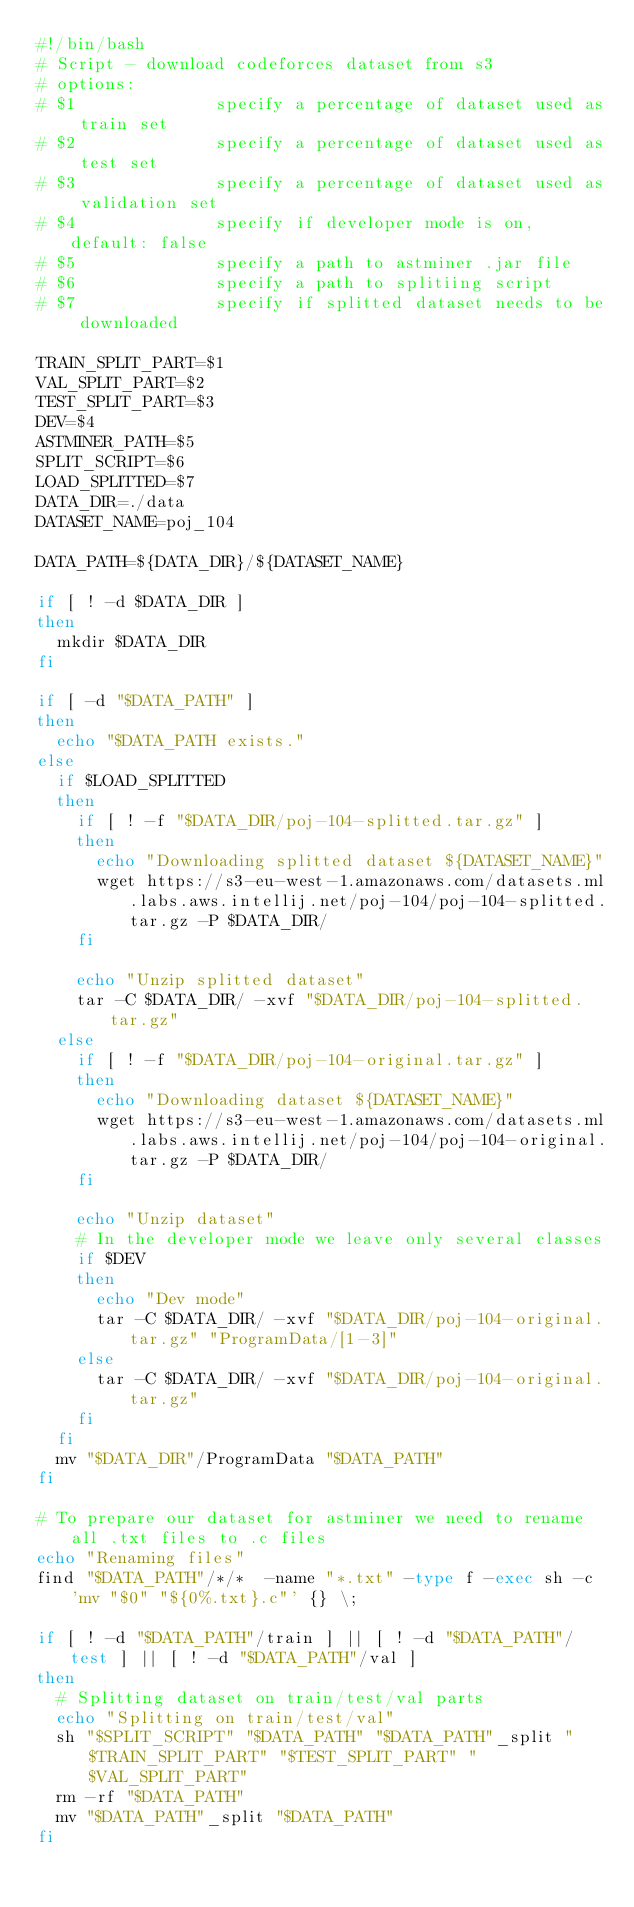<code> <loc_0><loc_0><loc_500><loc_500><_Bash_>#!/bin/bash
# Script - download codeforces dataset from s3
# options:
# $1              specify a percentage of dataset used as train set
# $2              specify a percentage of dataset used as test set
# $3              specify a percentage of dataset used as validation set
# $4              specify if developer mode is on, default: false
# $5              specify a path to astminer .jar file
# $6              specify a path to splitiing script
# $7              specify if splitted dataset needs to be downloaded

TRAIN_SPLIT_PART=$1
VAL_SPLIT_PART=$2
TEST_SPLIT_PART=$3
DEV=$4
ASTMINER_PATH=$5
SPLIT_SCRIPT=$6
LOAD_SPLITTED=$7
DATA_DIR=./data
DATASET_NAME=poj_104

DATA_PATH=${DATA_DIR}/${DATASET_NAME}

if [ ! -d $DATA_DIR ]
then
  mkdir $DATA_DIR
fi

if [ -d "$DATA_PATH" ]
then
  echo "$DATA_PATH exists."
else
  if $LOAD_SPLITTED
  then
    if [ ! -f "$DATA_DIR/poj-104-splitted.tar.gz" ]
    then
      echo "Downloading splitted dataset ${DATASET_NAME}"
      wget https://s3-eu-west-1.amazonaws.com/datasets.ml.labs.aws.intellij.net/poj-104/poj-104-splitted.tar.gz -P $DATA_DIR/
    fi

    echo "Unzip splitted dataset"
    tar -C $DATA_DIR/ -xvf "$DATA_DIR/poj-104-splitted.tar.gz"
  else
    if [ ! -f "$DATA_DIR/poj-104-original.tar.gz" ]
    then
      echo "Downloading dataset ${DATASET_NAME}"
      wget https://s3-eu-west-1.amazonaws.com/datasets.ml.labs.aws.intellij.net/poj-104/poj-104-original.tar.gz -P $DATA_DIR/
    fi

    echo "Unzip dataset"
    # In the developer mode we leave only several classes
    if $DEV
    then
      echo "Dev mode"
      tar -C $DATA_DIR/ -xvf "$DATA_DIR/poj-104-original.tar.gz" "ProgramData/[1-3]"
    else
      tar -C $DATA_DIR/ -xvf "$DATA_DIR/poj-104-original.tar.gz"
    fi
  fi
  mv "$DATA_DIR"/ProgramData "$DATA_PATH"
fi

# To prepare our dataset for astminer we need to rename all .txt files to .c files
echo "Renaming files"
find "$DATA_PATH"/*/*  -name "*.txt" -type f -exec sh -c 'mv "$0" "${0%.txt}.c"' {} \;

if [ ! -d "$DATA_PATH"/train ] || [ ! -d "$DATA_PATH"/test ] || [ ! -d "$DATA_PATH"/val ]
then
  # Splitting dataset on train/test/val parts
  echo "Splitting on train/test/val"
  sh "$SPLIT_SCRIPT" "$DATA_PATH" "$DATA_PATH"_split "$TRAIN_SPLIT_PART" "$TEST_SPLIT_PART" "$VAL_SPLIT_PART"
  rm -rf "$DATA_PATH"
  mv "$DATA_PATH"_split "$DATA_PATH"
fi
</code> 